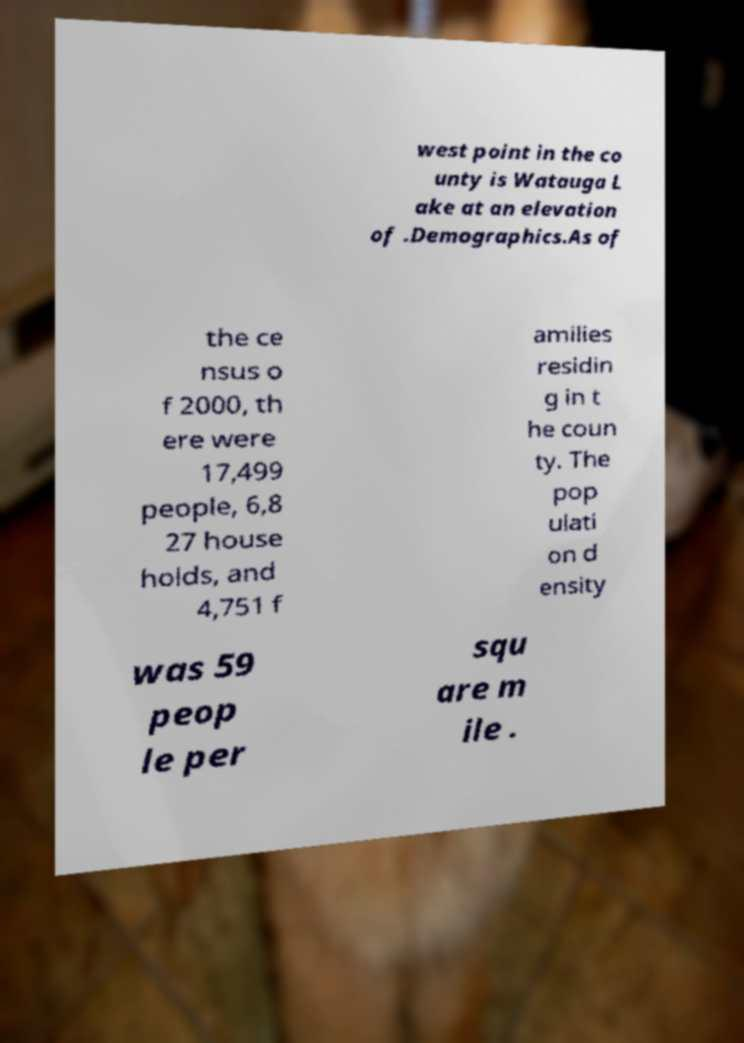What messages or text are displayed in this image? I need them in a readable, typed format. west point in the co unty is Watauga L ake at an elevation of .Demographics.As of the ce nsus o f 2000, th ere were 17,499 people, 6,8 27 house holds, and 4,751 f amilies residin g in t he coun ty. The pop ulati on d ensity was 59 peop le per squ are m ile . 